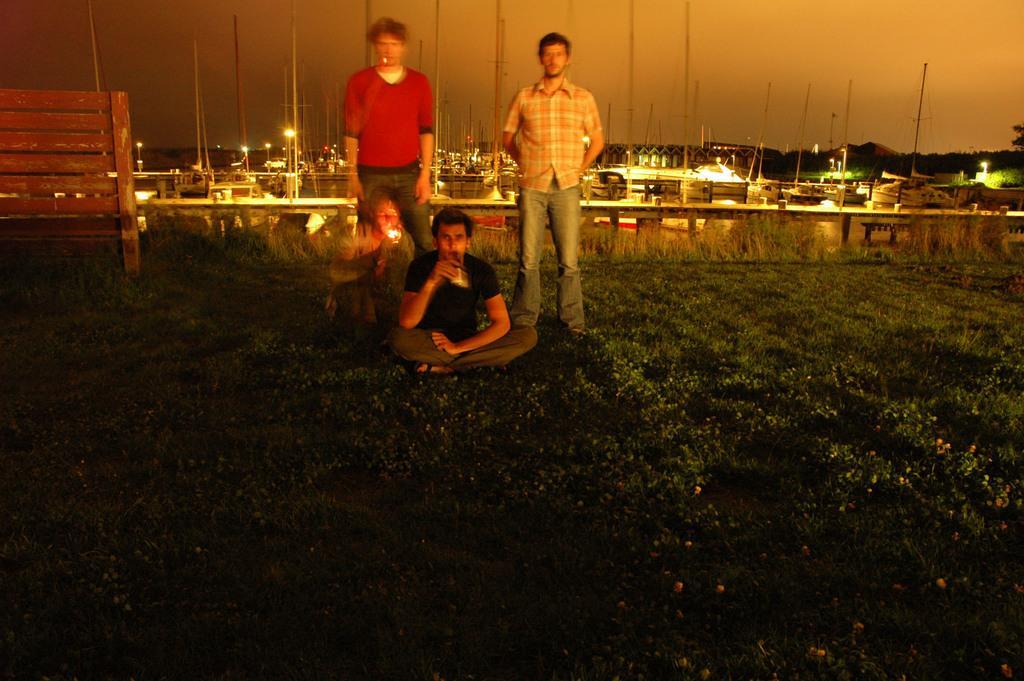Please provide a concise description of this image. This is an image clicked in the dark. At the bottom, I can see the grass on the ground. In the middle of the image there is a man holding a bottle in the hand and sitting on the ground. Behind him two men are standing and one person is holding a light in the hand and sitting. On the left side there is a bench. In the background there are many poles, lights and trees. At the top of the image I can see the sky. 